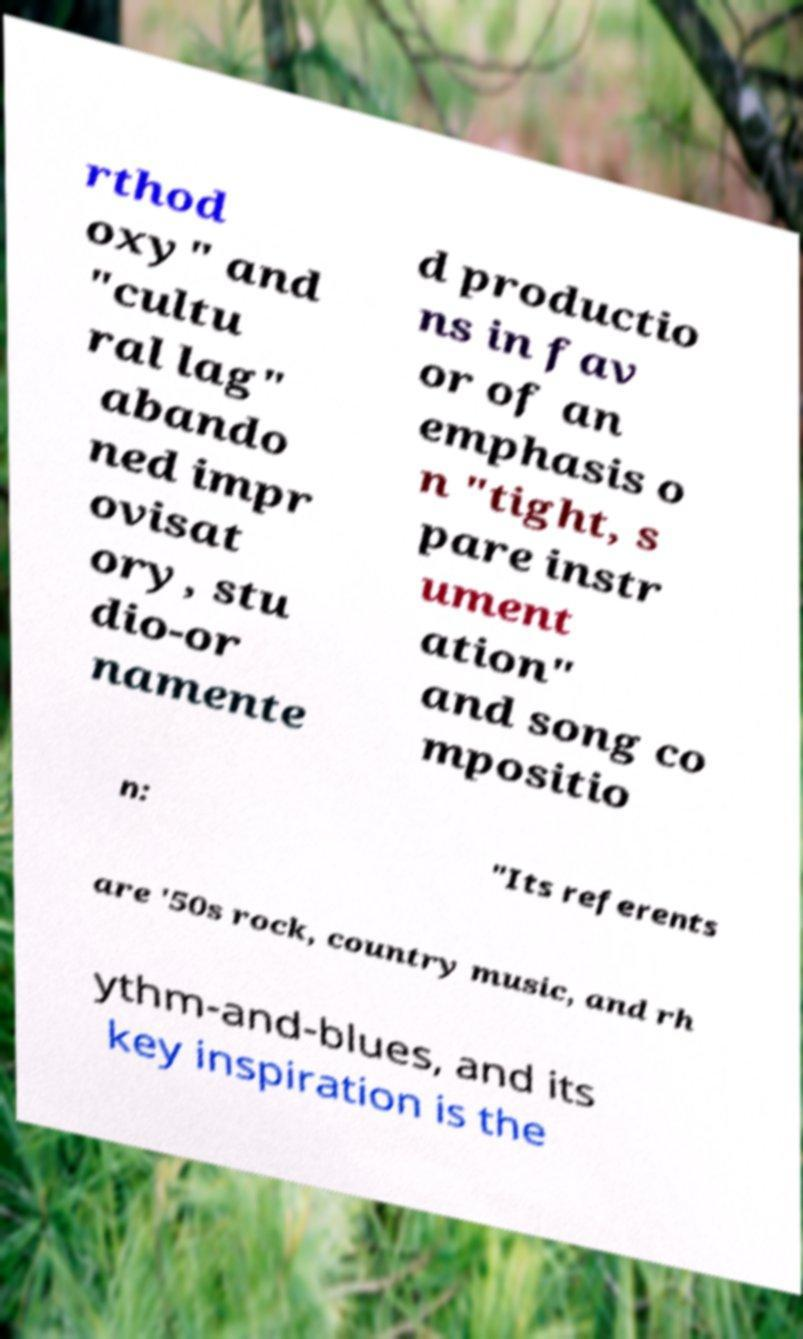For documentation purposes, I need the text within this image transcribed. Could you provide that? rthod oxy" and "cultu ral lag" abando ned impr ovisat ory, stu dio-or namente d productio ns in fav or of an emphasis o n "tight, s pare instr ument ation" and song co mpositio n: "Its referents are '50s rock, country music, and rh ythm-and-blues, and its key inspiration is the 